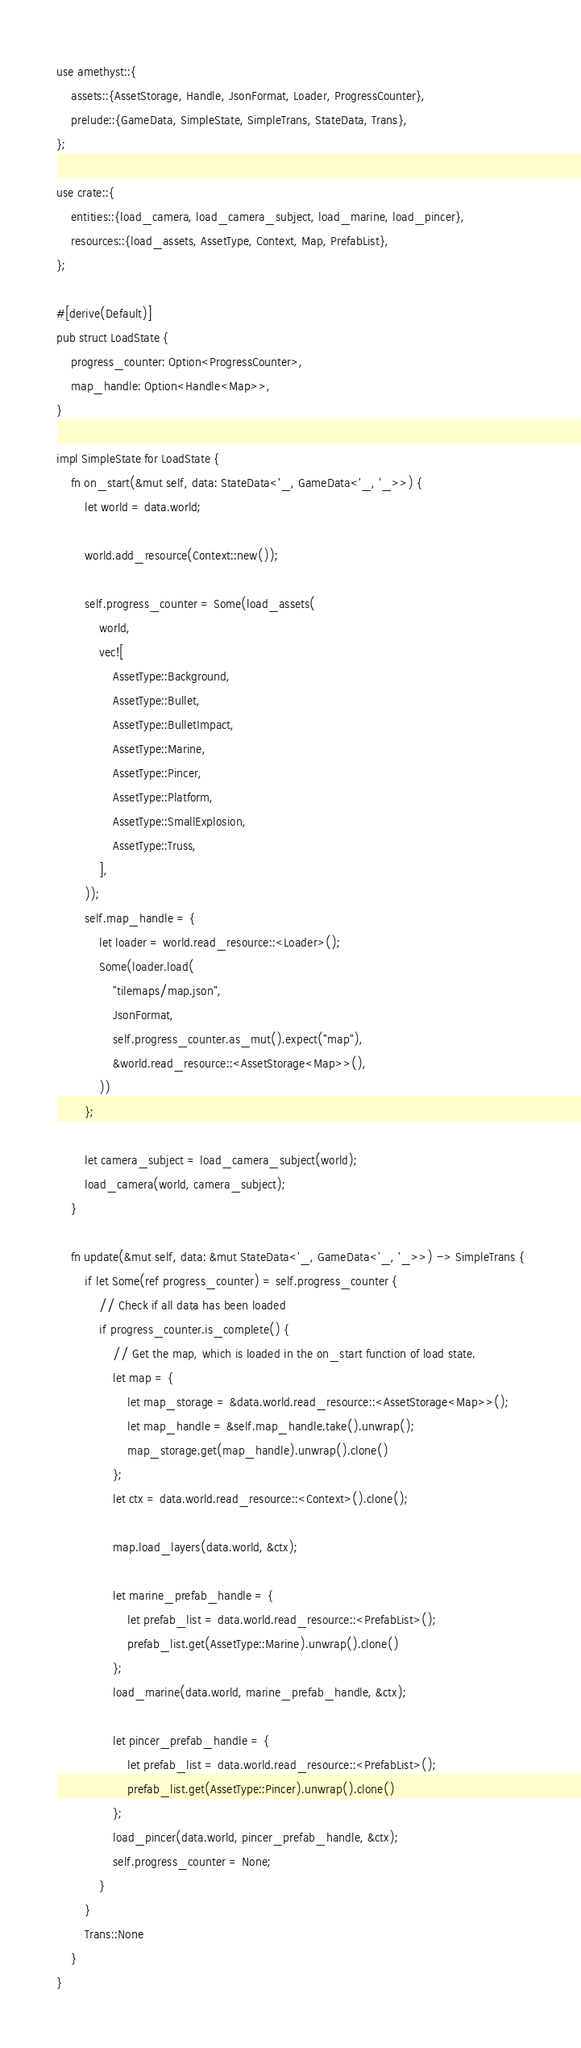Convert code to text. <code><loc_0><loc_0><loc_500><loc_500><_Rust_>use amethyst::{
    assets::{AssetStorage, Handle, JsonFormat, Loader, ProgressCounter},
    prelude::{GameData, SimpleState, SimpleTrans, StateData, Trans},
};

use crate::{
    entities::{load_camera, load_camera_subject, load_marine, load_pincer},
    resources::{load_assets, AssetType, Context, Map, PrefabList},
};

#[derive(Default)]
pub struct LoadState {
    progress_counter: Option<ProgressCounter>,
    map_handle: Option<Handle<Map>>,
}

impl SimpleState for LoadState {
    fn on_start(&mut self, data: StateData<'_, GameData<'_, '_>>) {
        let world = data.world;

        world.add_resource(Context::new());

        self.progress_counter = Some(load_assets(
            world,
            vec![
                AssetType::Background,
                AssetType::Bullet,
                AssetType::BulletImpact,
                AssetType::Marine,
                AssetType::Pincer,
                AssetType::Platform,
                AssetType::SmallExplosion,
                AssetType::Truss,
            ],
        ));
        self.map_handle = {
            let loader = world.read_resource::<Loader>();
            Some(loader.load(
                "tilemaps/map.json",
                JsonFormat,
                self.progress_counter.as_mut().expect("map"),
                &world.read_resource::<AssetStorage<Map>>(),
            ))
        };

        let camera_subject = load_camera_subject(world);
        load_camera(world, camera_subject);
    }

    fn update(&mut self, data: &mut StateData<'_, GameData<'_, '_>>) -> SimpleTrans {
        if let Some(ref progress_counter) = self.progress_counter {
            // Check if all data has been loaded
            if progress_counter.is_complete() {
                // Get the map, which is loaded in the on_start function of load state.
                let map = {
                    let map_storage = &data.world.read_resource::<AssetStorage<Map>>();
                    let map_handle = &self.map_handle.take().unwrap();
                    map_storage.get(map_handle).unwrap().clone()
                };
                let ctx = data.world.read_resource::<Context>().clone();

                map.load_layers(data.world, &ctx);

                let marine_prefab_handle = {
                    let prefab_list = data.world.read_resource::<PrefabList>();
                    prefab_list.get(AssetType::Marine).unwrap().clone()
                };
                load_marine(data.world, marine_prefab_handle, &ctx);

                let pincer_prefab_handle = {
                    let prefab_list = data.world.read_resource::<PrefabList>();
                    prefab_list.get(AssetType::Pincer).unwrap().clone()
                };
                load_pincer(data.world, pincer_prefab_handle, &ctx);
                self.progress_counter = None;
            }
        }
        Trans::None
    }
}
</code> 